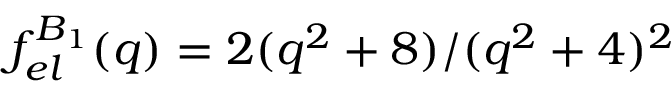Convert formula to latex. <formula><loc_0><loc_0><loc_500><loc_500>f _ { e l } ^ { B _ { 1 } } ( q ) = { 2 ( q ^ { 2 } + 8 ) } / { ( q ^ { 2 } + 4 ) ^ { 2 } }</formula> 